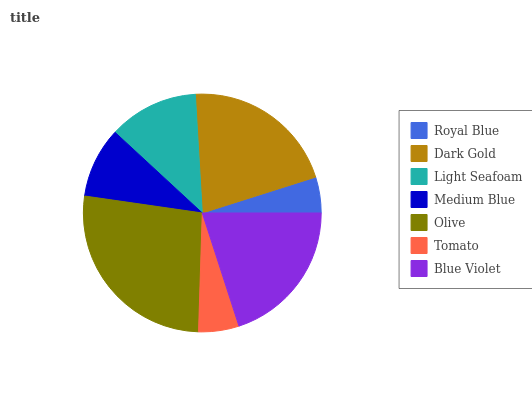Is Royal Blue the minimum?
Answer yes or no. Yes. Is Olive the maximum?
Answer yes or no. Yes. Is Dark Gold the minimum?
Answer yes or no. No. Is Dark Gold the maximum?
Answer yes or no. No. Is Dark Gold greater than Royal Blue?
Answer yes or no. Yes. Is Royal Blue less than Dark Gold?
Answer yes or no. Yes. Is Royal Blue greater than Dark Gold?
Answer yes or no. No. Is Dark Gold less than Royal Blue?
Answer yes or no. No. Is Light Seafoam the high median?
Answer yes or no. Yes. Is Light Seafoam the low median?
Answer yes or no. Yes. Is Medium Blue the high median?
Answer yes or no. No. Is Tomato the low median?
Answer yes or no. No. 